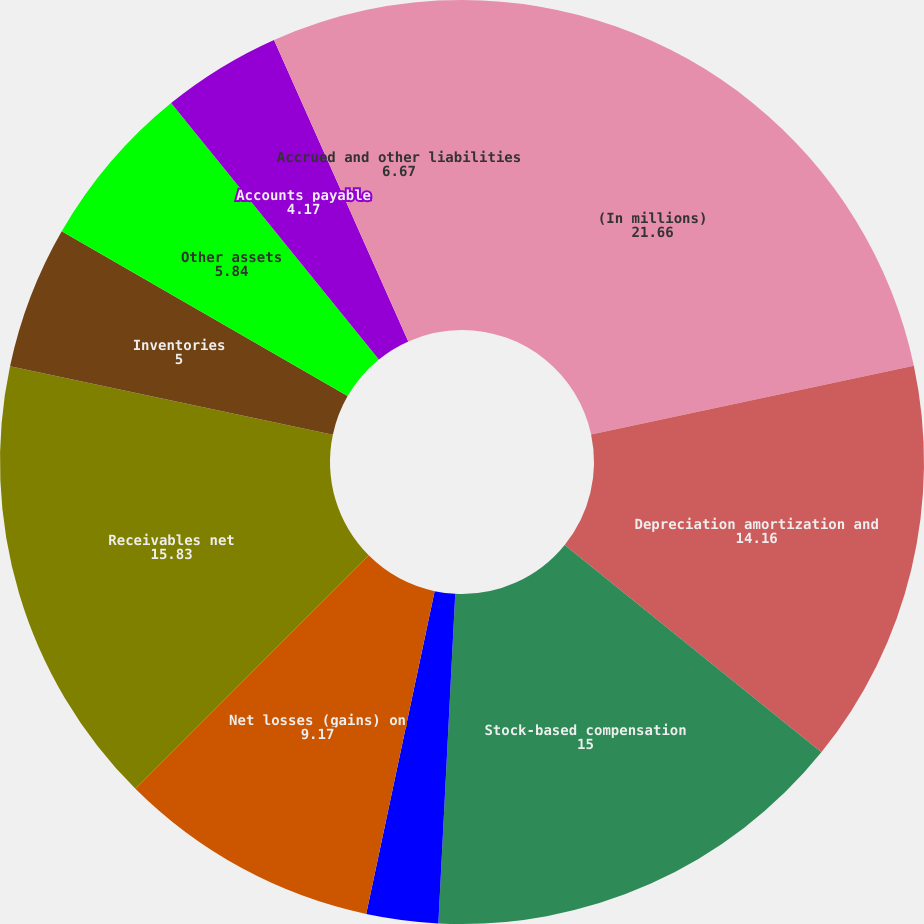Convert chart. <chart><loc_0><loc_0><loc_500><loc_500><pie_chart><fcel>(In millions)<fcel>Depreciation amortization and<fcel>Stock-based compensation<fcel>Other non-cash restructuring<fcel>Net losses (gains) on<fcel>Receivables net<fcel>Inventories<fcel>Other assets<fcel>Accounts payable<fcel>Accrued and other liabilities<nl><fcel>21.66%<fcel>14.16%<fcel>15.0%<fcel>2.51%<fcel>9.17%<fcel>15.83%<fcel>5.0%<fcel>5.84%<fcel>4.17%<fcel>6.67%<nl></chart> 